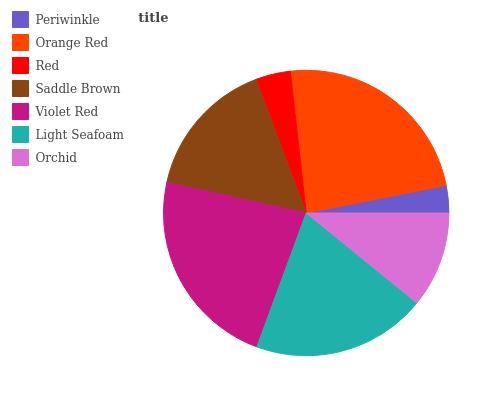Is Periwinkle the minimum?
Answer yes or no. Yes. Is Orange Red the maximum?
Answer yes or no. Yes. Is Red the minimum?
Answer yes or no. No. Is Red the maximum?
Answer yes or no. No. Is Orange Red greater than Red?
Answer yes or no. Yes. Is Red less than Orange Red?
Answer yes or no. Yes. Is Red greater than Orange Red?
Answer yes or no. No. Is Orange Red less than Red?
Answer yes or no. No. Is Saddle Brown the high median?
Answer yes or no. Yes. Is Saddle Brown the low median?
Answer yes or no. Yes. Is Periwinkle the high median?
Answer yes or no. No. Is Light Seafoam the low median?
Answer yes or no. No. 